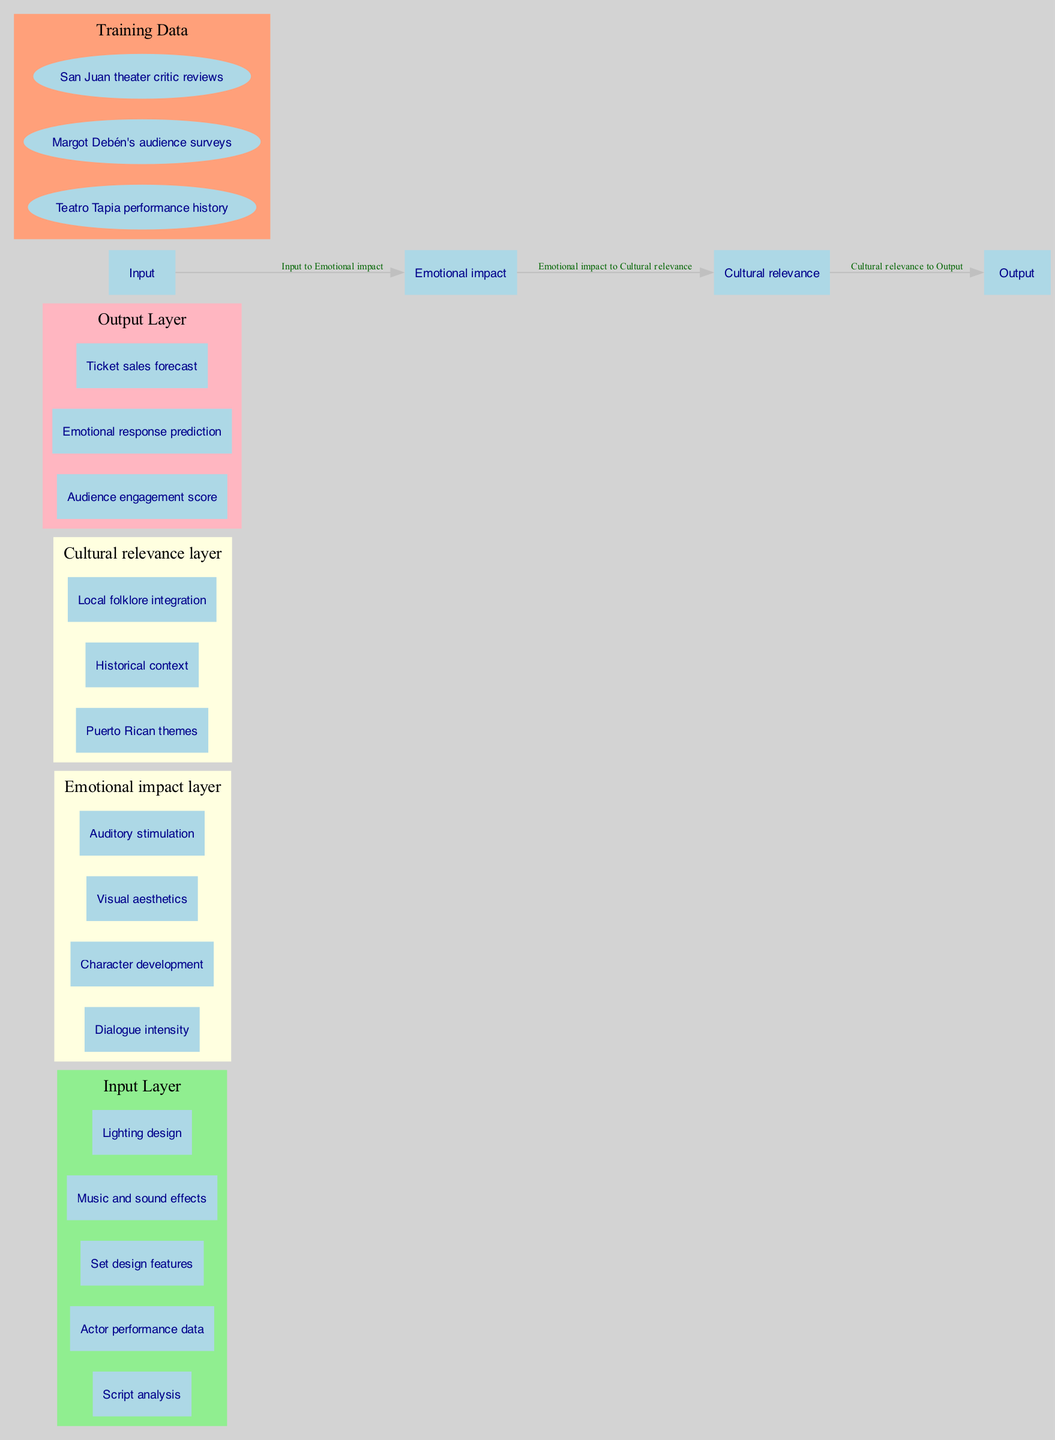What are the inputs to the neural network? The inputs to the neural network are defined in the input layer, which includes "Script analysis," "Actor performance data," "Set design features," "Music and sound effects," and "Lighting design."
Answer: Script analysis, Actor performance data, Set design features, Music and sound effects, Lighting design How many nodes are in the Emotional impact layer? The Emotional impact layer has four nodes: "Dialogue intensity," "Character development," "Visual aesthetics," and "Auditory stimulation." Count these nodes for the total.
Answer: 4 What is the output of the neural network? The output layer contains three nodes: "Audience engagement score," "Emotional response prediction," and "Ticket sales forecast," indicating the results produced by the neural network.
Answer: Audience engagement score, Emotional response prediction, Ticket sales forecast Which hidden layer connects to the output layer? The output layer is directly connected to the "Cultural relevance layer," as indicated in the connections listed in the diagram.
Answer: Cultural relevance layer What type of data is used for training the neural network? The training data used includes "Teatro Tapia performance history," "Margot Debén's audience surveys," and "San Juan theater critic reviews," which are categorized in the training data section of the diagram.
Answer: Teatro Tapia performance history, Margot Debén's audience surveys, San Juan theater critic reviews Which node is last in the hierarchy from input to output? To determine the last node, we follow the connections through the layers, leading from input nodes to the Emotional impact layer, then to the Cultural relevance layer, and finally to the outputs. The last node in this flow is part of the output layer.
Answer: Ticket sales forecast How many layers are present in this neural network architecture? The architecture includes an input layer, two hidden layers (Emotional impact and Cultural relevance), and one output layer, which totals to four layers.
Answer: 4 What is the primary focus of the Cultural relevance layer? The nodes in the Cultural relevance layer focus on "Puerto Rican themes," "Historical context," and "Local folklore integration," which reflect the layer's thematic emphasis as specified in the diagram.
Answer: Puerto Rican themes, Historical context, Local folklore integration 